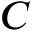<formula> <loc_0><loc_0><loc_500><loc_500>C</formula> 